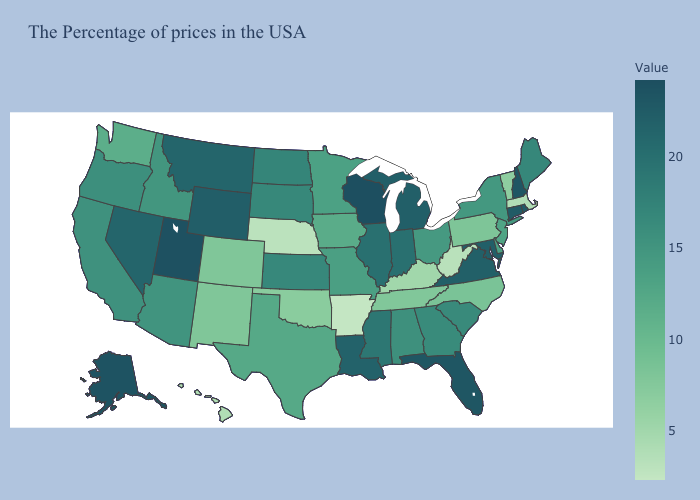Is the legend a continuous bar?
Short answer required. Yes. Among the states that border Georgia , which have the lowest value?
Write a very short answer. Tennessee. Does Massachusetts have the highest value in the Northeast?
Write a very short answer. No. Which states have the lowest value in the West?
Give a very brief answer. Hawaii. Which states hav the highest value in the West?
Quick response, please. Utah. 